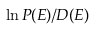<formula> <loc_0><loc_0><loc_500><loc_500>\ln P ( E ) / D ( E )</formula> 